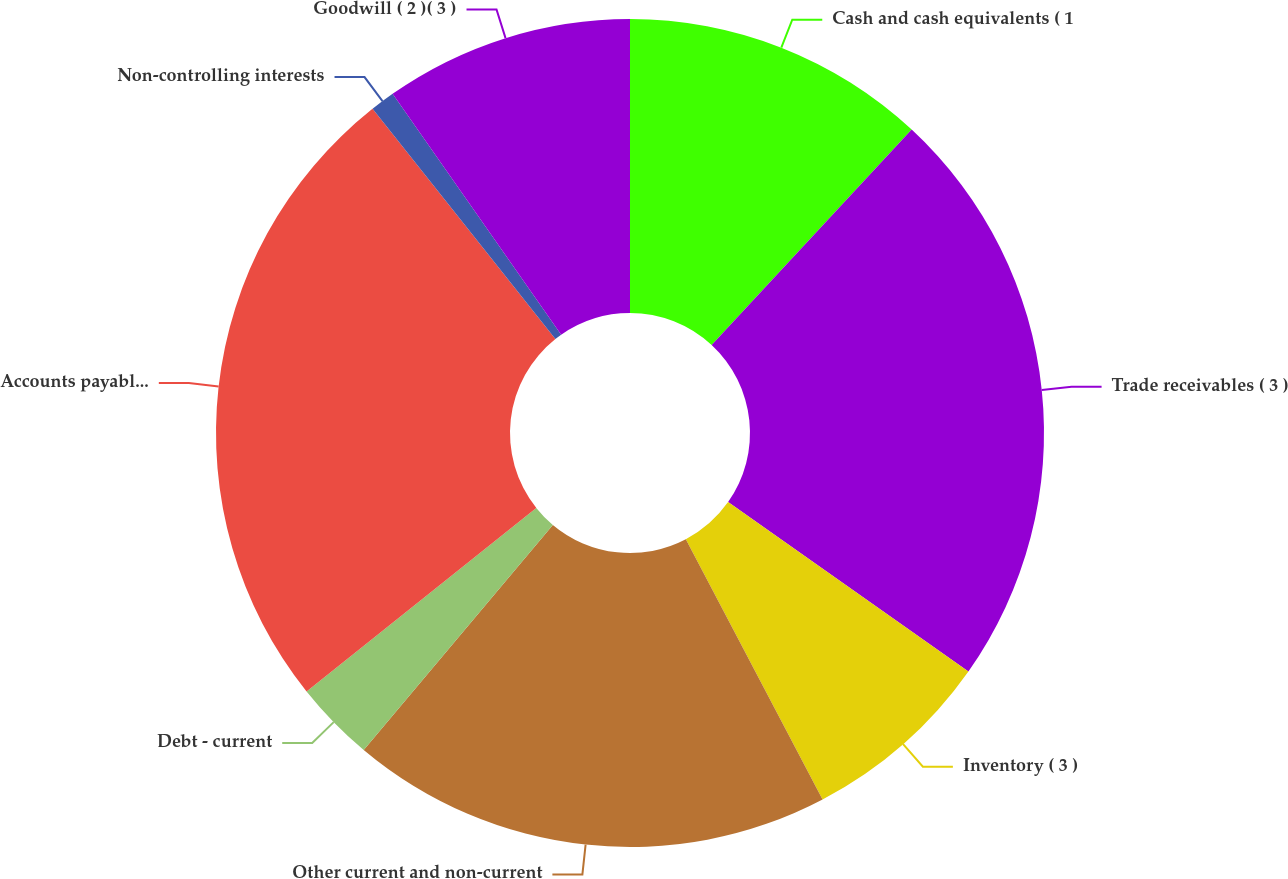<chart> <loc_0><loc_0><loc_500><loc_500><pie_chart><fcel>Cash and cash equivalents ( 1<fcel>Trade receivables ( 3 )<fcel>Inventory ( 3 )<fcel>Other current and non-current<fcel>Debt - current<fcel>Accounts payable and accrued<fcel>Non-controlling interests<fcel>Goodwill ( 2 )( 3 )<nl><fcel>11.91%<fcel>22.86%<fcel>7.53%<fcel>18.82%<fcel>3.15%<fcel>25.05%<fcel>0.96%<fcel>9.72%<nl></chart> 